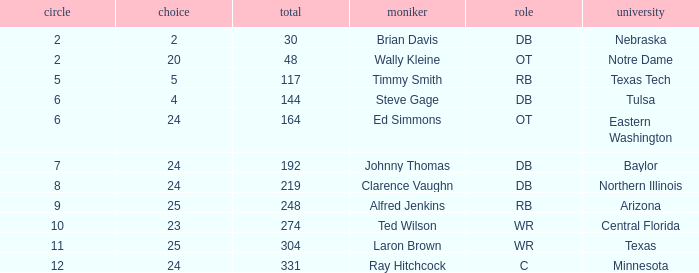Could you parse the entire table? {'header': ['circle', 'choice', 'total', 'moniker', 'role', 'university'], 'rows': [['2', '2', '30', 'Brian Davis', 'DB', 'Nebraska'], ['2', '20', '48', 'Wally Kleine', 'OT', 'Notre Dame'], ['5', '5', '117', 'Timmy Smith', 'RB', 'Texas Tech'], ['6', '4', '144', 'Steve Gage', 'DB', 'Tulsa'], ['6', '24', '164', 'Ed Simmons', 'OT', 'Eastern Washington'], ['7', '24', '192', 'Johnny Thomas', 'DB', 'Baylor'], ['8', '24', '219', 'Clarence Vaughn', 'DB', 'Northern Illinois'], ['9', '25', '248', 'Alfred Jenkins', 'RB', 'Arizona'], ['10', '23', '274', 'Ted Wilson', 'WR', 'Central Florida'], ['11', '25', '304', 'Laron Brown', 'WR', 'Texas'], ['12', '24', '331', 'Ray Hitchcock', 'C', 'Minnesota']]} What top round has a pick smaller than 2? None. 